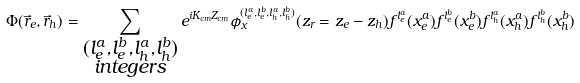<formula> <loc_0><loc_0><loc_500><loc_500>\Phi ( \vec { r } _ { e } , \vec { r } _ { h } ) = \sum _ { \substack { ( l _ { e } ^ { a } , l _ { e } ^ { b } , l _ { h } ^ { a } , l _ { h } ^ { b } ) \\ i n t e g e r s } } e ^ { i K _ { c m } Z _ { c m } } \phi _ { x } ^ { ( l _ { e } ^ { a } , l _ { e } ^ { b } , l _ { h } ^ { a } , l _ { h } ^ { b } ) } ( z _ { r } = z _ { e } - z _ { h } ) f ^ { l _ { e } ^ { a } } ( x _ { e } ^ { a } ) f ^ { l _ { e } ^ { b } } ( x _ { e } ^ { b } ) f ^ { l _ { h } ^ { a } } ( x _ { h } ^ { a } ) f ^ { l _ { h } ^ { b } } ( x _ { h } ^ { b } )</formula> 